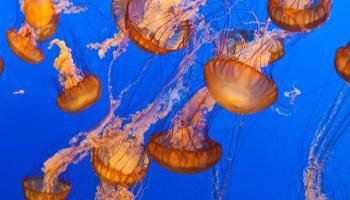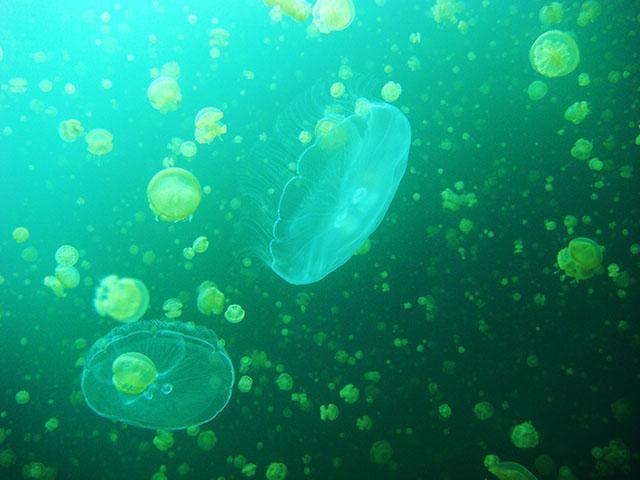The first image is the image on the left, the second image is the image on the right. Given the left and right images, does the statement "All the jellyfish in one image are purplish-pink in color." hold true? Answer yes or no. No. The first image is the image on the left, the second image is the image on the right. For the images displayed, is the sentence "There is at least one orange colored jellyfish." factually correct? Answer yes or no. Yes. 